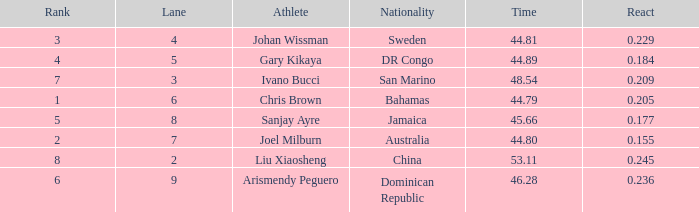What is the total average for Rank entries where the Lane listed is smaller than 4 and the Nationality listed is San Marino? 7.0. 